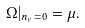Convert formula to latex. <formula><loc_0><loc_0><loc_500><loc_500>\Omega | _ { n _ { \nu } = 0 } = \mu .</formula> 